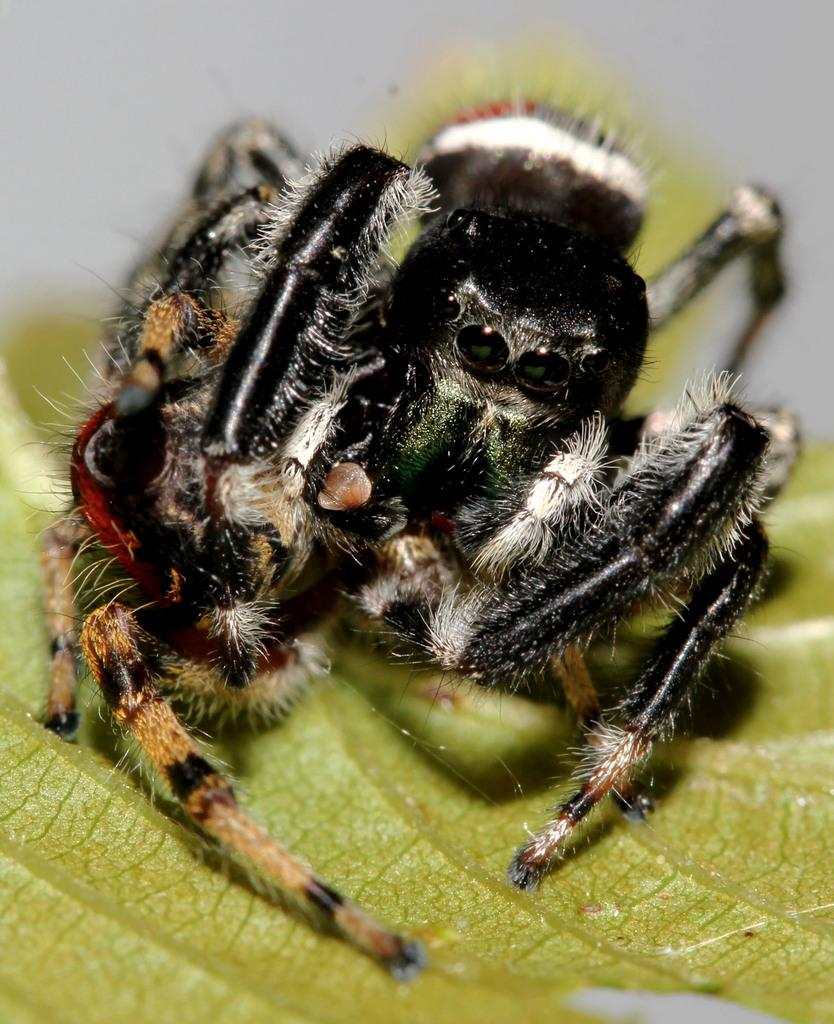What is present on the leaf in the image? There is an insect on the leaf in the image. Can you describe the insect's location in relation to the leaf? The insect is on the leaf. What type of bed can be seen in the image? There is no bed present in the image; it features an insect on a leaf. How many pigs are visible in the image? There are no pigs present in the image. 